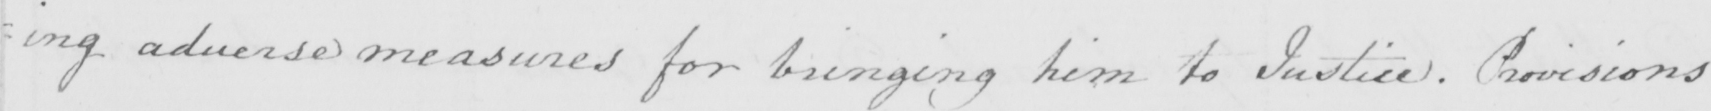Please provide the text content of this handwritten line. : ing adverses measures for bringing him to Justice . Provisions 